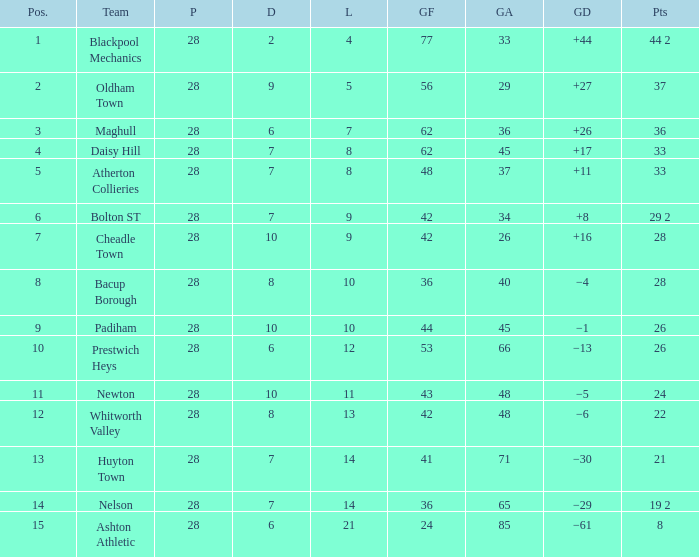For entries with lost larger than 21 and goals for smaller than 36, what is the average drawn? None. 